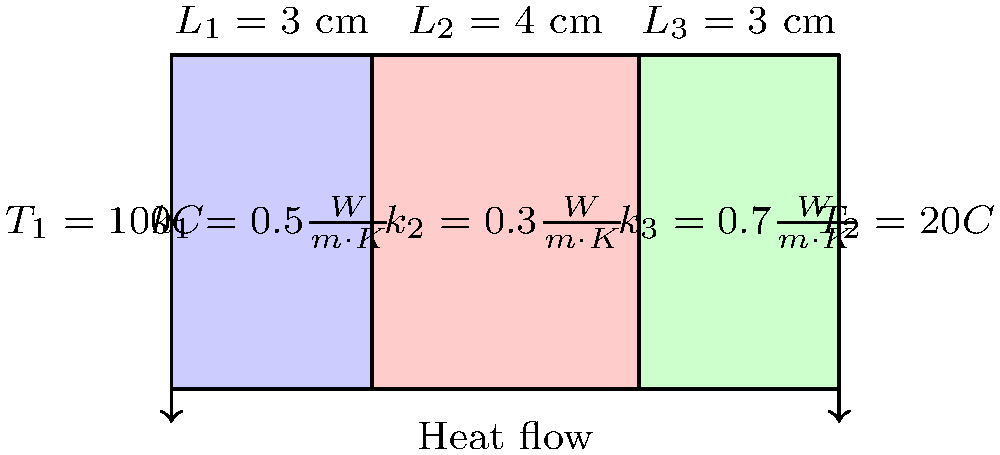A composite wall consists of three layers with different thermal conductivities and thicknesses as shown in the diagram. The temperature on the left side of the wall is 100°C, and on the right side is 20°C. Calculate the heat flux through the wall in W/m². To solve this problem, we'll use the concept of thermal resistance in series and Fourier's law of heat conduction. Let's follow these steps:

1) Calculate the thermal resistance of each layer:
   $R_i = \frac{L_i}{k_i}$, where $L_i$ is the thickness and $k_i$ is the thermal conductivity.
   
   $R_1 = \frac{0.03}{0.5} = 0.06 \frac{m^2 \cdot K}{W}$
   $R_2 = \frac{0.04}{0.3} = 0.1333 \frac{m^2 \cdot K}{W}$
   $R_3 = \frac{0.03}{0.7} = 0.0429 \frac{m^2 \cdot K}{W}$

2) Calculate the total thermal resistance:
   $R_{total} = R_1 + R_2 + R_3 = 0.06 + 0.1333 + 0.0429 = 0.2362 \frac{m^2 \cdot K}{W}$

3) Use Fourier's law to calculate the heat flux:
   $q = \frac{\Delta T}{R_{total}}$, where $\Delta T$ is the temperature difference.
   
   $q = \frac{100°C - 20°C}{0.2362 \frac{m^2 \cdot K}{W}} = \frac{80}{0.2362} = 338.7 \frac{W}{m^2}$

Therefore, the heat flux through the wall is approximately 338.7 W/m².
Answer: 338.7 W/m² 